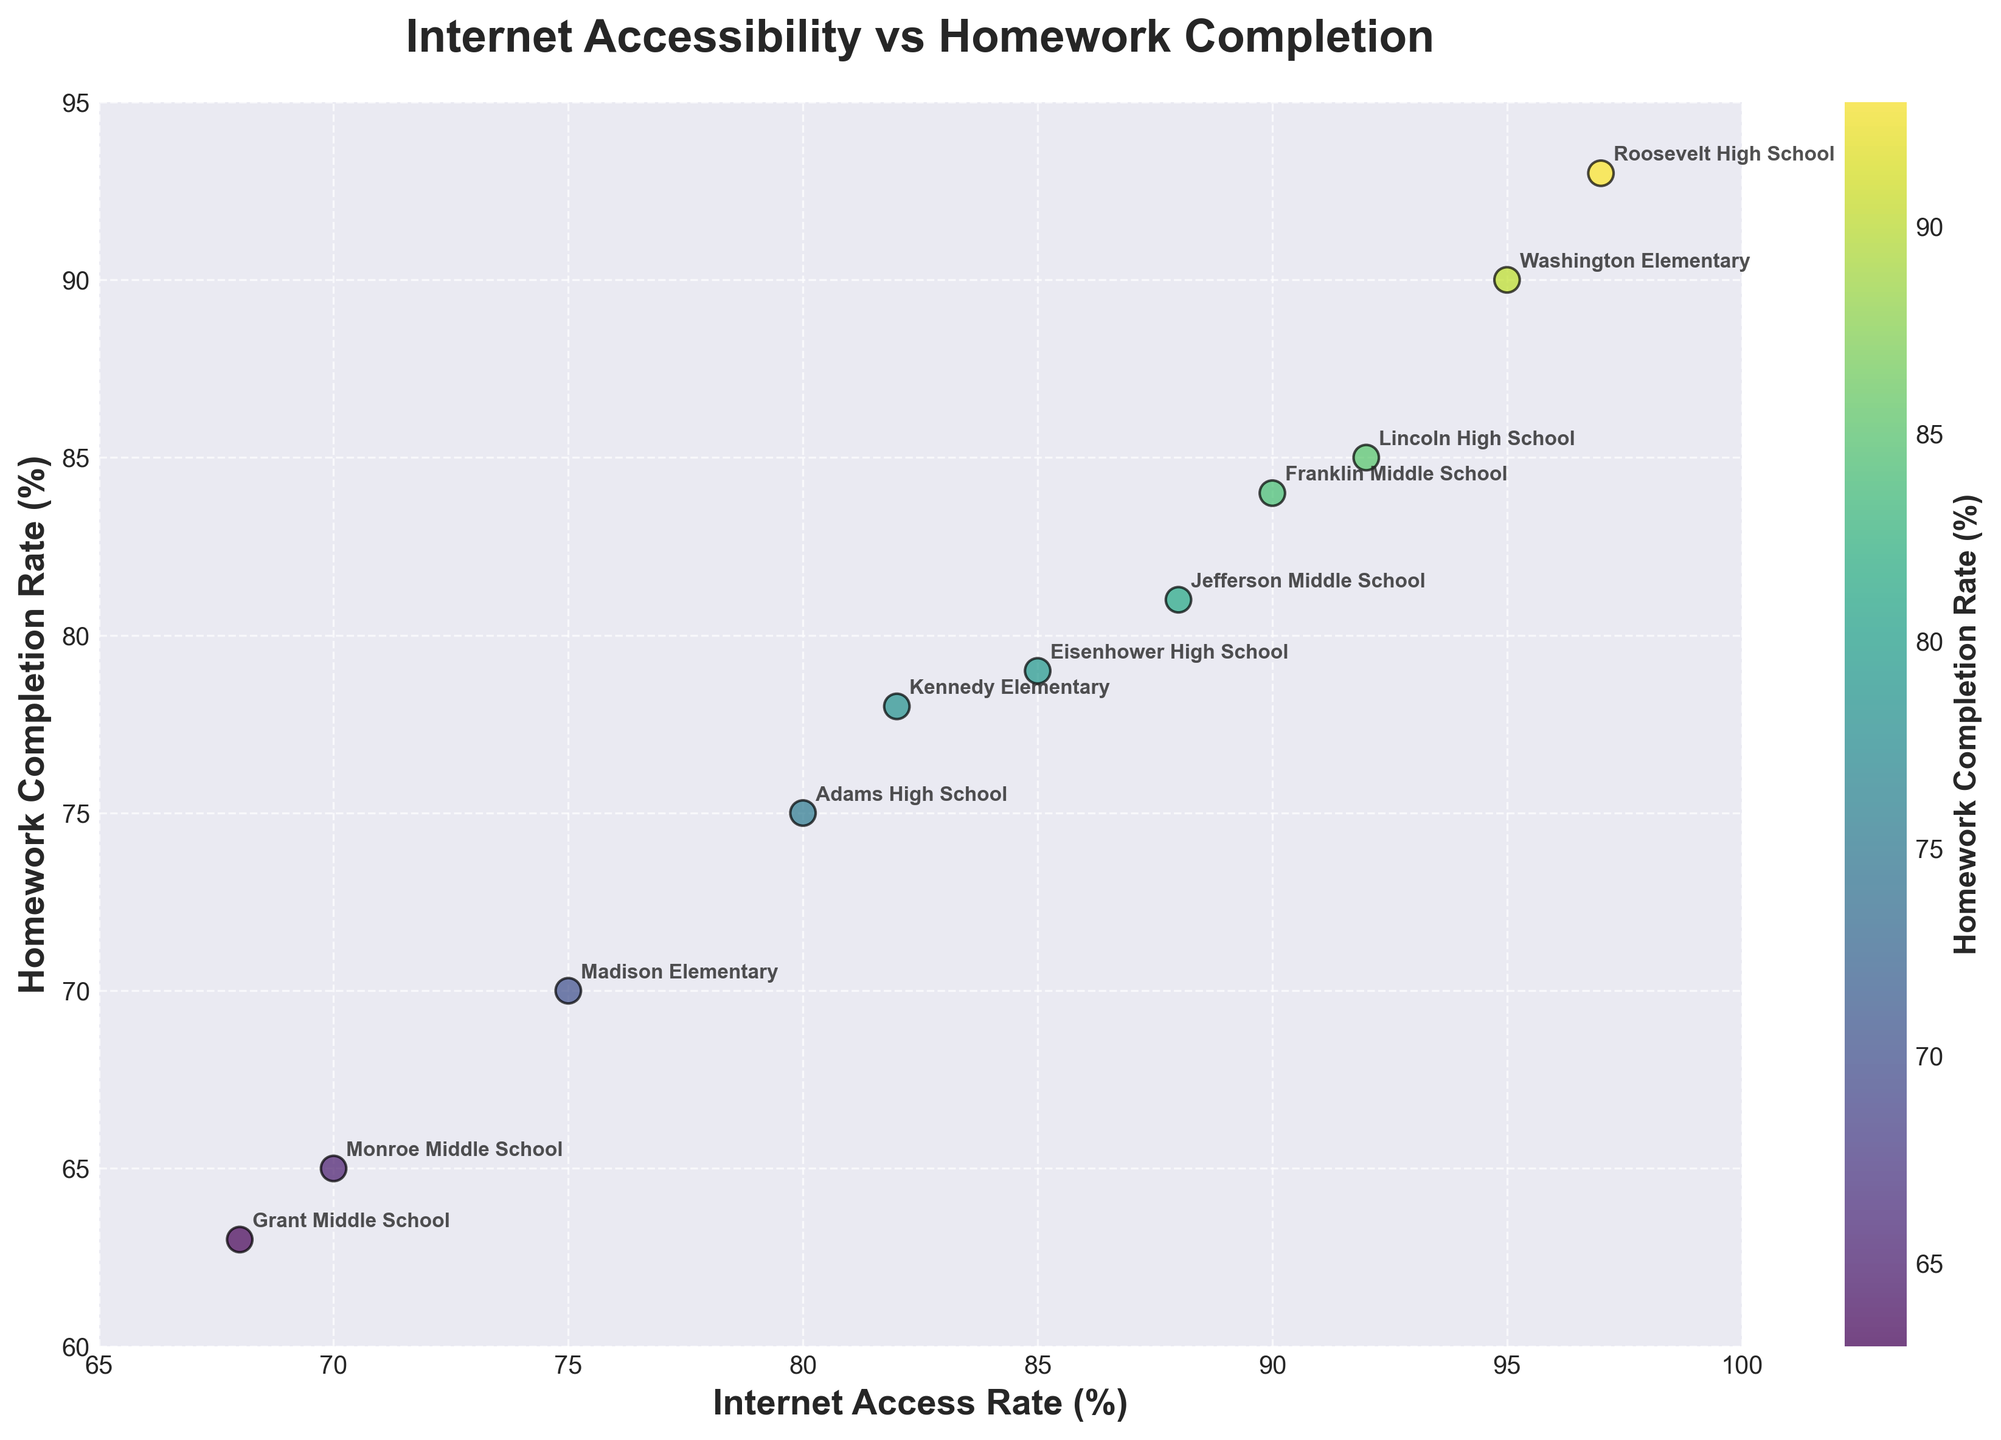What's the title of the plot? The title of the plot is displayed at the top in bold and large font. It reads "Internet Accessibility vs Homework Completion".
Answer: Internet Accessibility vs Homework Completion How many schools are shown in the scatter plot? To find the number of schools, you can count the number of data points or the number of labels annotated on the plot. Each represents one school.
Answer: 11 Which school has the highest Internet Access Rate? Look for the data point positioned furthest to the right on the x-axis and check its label. This corresponds to the school with the highest Internet Access Rate.
Answer: Roosevelt High School Which school has the lowest Homework Completion Rate? Identify the data point that is located the lowest on the y-axis. The label next to this point will indicate the school with the lowest Homework Completion Rate.
Answer: Grant Middle School What is the relationship between Internet Access Rate and Homework Completion Rate in the plot? By observing the scatter plot, you can see that as the Internet Access Rate increases, the Homework Completion Rate tends to increase as well, indicating a positive correlation.
Answer: Positive correlation Which school has a Homework Completion Rate higher than 80% but lower Internet Access Rate than 90%? Find the data points where the y-value (Homework Completion Rate) is above 80% and the x-value (Internet Access Rate) is below 90%. Identify the corresponding school from the labels.
Answer: Franklin Middle School Compare the Homework Completion Rates of Washington Elementary and Eisenhower High School. Which one is higher? Locate both schools on the plot and compare their positions on the y-axis. Washington Elementary's point is higher on the y-axis than Eisenhower High School's point, indicating a higher rate.
Answer: Washington Elementary What is the range of Internet Access Rates among the schools? Identify the minimum and maximum values on the x-axis by observing the furthest left and right data points. The range is the difference between these two values.
Answer: 29% (from 68% to 97%) How many schools have an Internet Access Rate of 90% or above? Count the number of data points that are positioned at 90% or higher on the x-axis.
Answer: 5 If we categorize schools into those with Homework Completion Rates above and below 80%, which category has more schools? Count the number of data points above the 80% line on the y-axis and compare with those below it.
Answer: Above 80% 